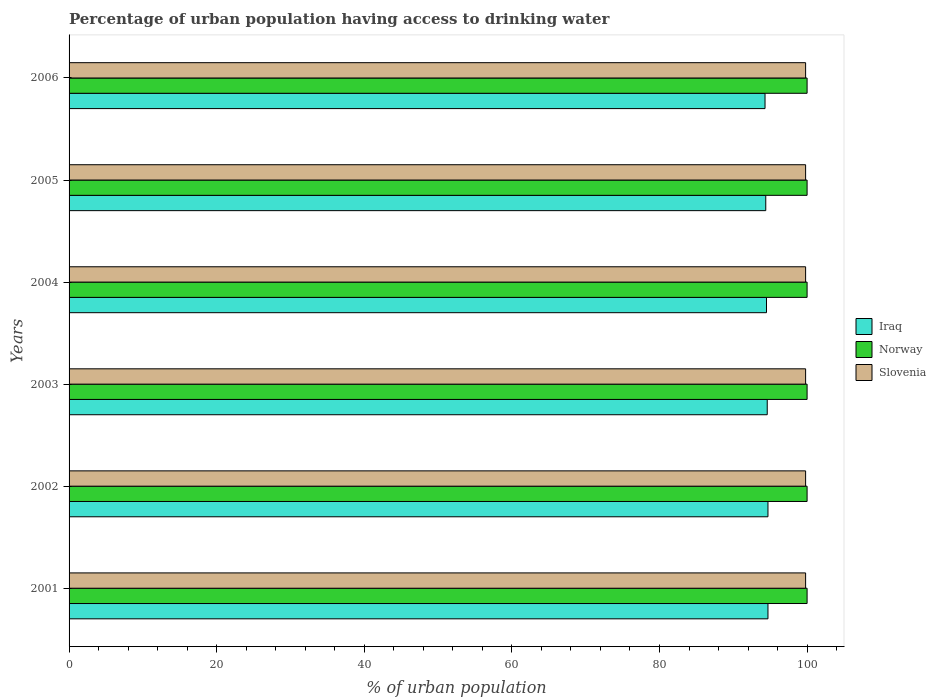How many groups of bars are there?
Make the answer very short. 6. Are the number of bars per tick equal to the number of legend labels?
Give a very brief answer. Yes. What is the label of the 5th group of bars from the top?
Provide a short and direct response. 2002. What is the percentage of urban population having access to drinking water in Slovenia in 2004?
Make the answer very short. 99.8. Across all years, what is the maximum percentage of urban population having access to drinking water in Norway?
Provide a succinct answer. 100. Across all years, what is the minimum percentage of urban population having access to drinking water in Norway?
Keep it short and to the point. 100. In which year was the percentage of urban population having access to drinking water in Norway minimum?
Provide a short and direct response. 2001. What is the total percentage of urban population having access to drinking water in Slovenia in the graph?
Keep it short and to the point. 598.8. What is the difference between the percentage of urban population having access to drinking water in Iraq in 2002 and that in 2005?
Your answer should be very brief. 0.3. What is the difference between the percentage of urban population having access to drinking water in Iraq in 2004 and the percentage of urban population having access to drinking water in Norway in 2001?
Provide a short and direct response. -5.5. In the year 2002, what is the difference between the percentage of urban population having access to drinking water in Iraq and percentage of urban population having access to drinking water in Norway?
Ensure brevity in your answer.  -5.3. In how many years, is the percentage of urban population having access to drinking water in Norway greater than 80 %?
Provide a short and direct response. 6. Is the percentage of urban population having access to drinking water in Norway in 2001 less than that in 2003?
Provide a succinct answer. No. Is the difference between the percentage of urban population having access to drinking water in Iraq in 2002 and 2006 greater than the difference between the percentage of urban population having access to drinking water in Norway in 2002 and 2006?
Give a very brief answer. Yes. What is the difference between the highest and the second highest percentage of urban population having access to drinking water in Norway?
Give a very brief answer. 0. What is the difference between the highest and the lowest percentage of urban population having access to drinking water in Norway?
Offer a very short reply. 0. What does the 1st bar from the top in 2006 represents?
Provide a short and direct response. Slovenia. What does the 1st bar from the bottom in 2003 represents?
Provide a succinct answer. Iraq. How many bars are there?
Provide a short and direct response. 18. How many years are there in the graph?
Offer a terse response. 6. What is the difference between two consecutive major ticks on the X-axis?
Your response must be concise. 20. Are the values on the major ticks of X-axis written in scientific E-notation?
Make the answer very short. No. Does the graph contain any zero values?
Your response must be concise. No. Does the graph contain grids?
Provide a short and direct response. No. Where does the legend appear in the graph?
Ensure brevity in your answer.  Center right. How many legend labels are there?
Provide a short and direct response. 3. What is the title of the graph?
Your response must be concise. Percentage of urban population having access to drinking water. Does "Jamaica" appear as one of the legend labels in the graph?
Ensure brevity in your answer.  No. What is the label or title of the X-axis?
Provide a short and direct response. % of urban population. What is the label or title of the Y-axis?
Offer a very short reply. Years. What is the % of urban population in Iraq in 2001?
Provide a succinct answer. 94.7. What is the % of urban population of Slovenia in 2001?
Give a very brief answer. 99.8. What is the % of urban population of Iraq in 2002?
Give a very brief answer. 94.7. What is the % of urban population in Slovenia in 2002?
Your answer should be compact. 99.8. What is the % of urban population of Iraq in 2003?
Keep it short and to the point. 94.6. What is the % of urban population of Slovenia in 2003?
Give a very brief answer. 99.8. What is the % of urban population in Iraq in 2004?
Make the answer very short. 94.5. What is the % of urban population of Slovenia in 2004?
Provide a succinct answer. 99.8. What is the % of urban population in Iraq in 2005?
Make the answer very short. 94.4. What is the % of urban population of Norway in 2005?
Your answer should be very brief. 100. What is the % of urban population in Slovenia in 2005?
Offer a very short reply. 99.8. What is the % of urban population in Iraq in 2006?
Your answer should be very brief. 94.3. What is the % of urban population of Norway in 2006?
Your answer should be compact. 100. What is the % of urban population in Slovenia in 2006?
Your response must be concise. 99.8. Across all years, what is the maximum % of urban population of Iraq?
Your answer should be compact. 94.7. Across all years, what is the maximum % of urban population in Norway?
Your answer should be compact. 100. Across all years, what is the maximum % of urban population of Slovenia?
Ensure brevity in your answer.  99.8. Across all years, what is the minimum % of urban population in Iraq?
Give a very brief answer. 94.3. Across all years, what is the minimum % of urban population of Norway?
Keep it short and to the point. 100. Across all years, what is the minimum % of urban population of Slovenia?
Your response must be concise. 99.8. What is the total % of urban population in Iraq in the graph?
Give a very brief answer. 567.2. What is the total % of urban population in Norway in the graph?
Ensure brevity in your answer.  600. What is the total % of urban population of Slovenia in the graph?
Your response must be concise. 598.8. What is the difference between the % of urban population of Slovenia in 2001 and that in 2003?
Your answer should be very brief. 0. What is the difference between the % of urban population of Iraq in 2001 and that in 2004?
Offer a terse response. 0.2. What is the difference between the % of urban population in Norway in 2001 and that in 2004?
Make the answer very short. 0. What is the difference between the % of urban population in Iraq in 2001 and that in 2005?
Ensure brevity in your answer.  0.3. What is the difference between the % of urban population in Norway in 2001 and that in 2005?
Offer a very short reply. 0. What is the difference between the % of urban population in Iraq in 2001 and that in 2006?
Your response must be concise. 0.4. What is the difference between the % of urban population in Slovenia in 2001 and that in 2006?
Offer a very short reply. 0. What is the difference between the % of urban population in Iraq in 2002 and that in 2003?
Offer a terse response. 0.1. What is the difference between the % of urban population of Norway in 2002 and that in 2003?
Keep it short and to the point. 0. What is the difference between the % of urban population in Slovenia in 2002 and that in 2003?
Your answer should be compact. 0. What is the difference between the % of urban population of Iraq in 2002 and that in 2004?
Ensure brevity in your answer.  0.2. What is the difference between the % of urban population in Norway in 2002 and that in 2004?
Your answer should be very brief. 0. What is the difference between the % of urban population of Slovenia in 2002 and that in 2004?
Provide a short and direct response. 0. What is the difference between the % of urban population in Slovenia in 2002 and that in 2006?
Your answer should be very brief. 0. What is the difference between the % of urban population in Iraq in 2003 and that in 2004?
Make the answer very short. 0.1. What is the difference between the % of urban population in Norway in 2003 and that in 2004?
Give a very brief answer. 0. What is the difference between the % of urban population in Iraq in 2003 and that in 2005?
Keep it short and to the point. 0.2. What is the difference between the % of urban population of Norway in 2003 and that in 2005?
Offer a terse response. 0. What is the difference between the % of urban population of Slovenia in 2003 and that in 2005?
Offer a very short reply. 0. What is the difference between the % of urban population in Norway in 2003 and that in 2006?
Provide a succinct answer. 0. What is the difference between the % of urban population in Slovenia in 2003 and that in 2006?
Ensure brevity in your answer.  0. What is the difference between the % of urban population of Iraq in 2004 and that in 2005?
Provide a short and direct response. 0.1. What is the difference between the % of urban population in Iraq in 2004 and that in 2006?
Your answer should be very brief. 0.2. What is the difference between the % of urban population of Norway in 2005 and that in 2006?
Your answer should be very brief. 0. What is the difference between the % of urban population in Slovenia in 2005 and that in 2006?
Provide a short and direct response. 0. What is the difference between the % of urban population of Iraq in 2001 and the % of urban population of Norway in 2002?
Keep it short and to the point. -5.3. What is the difference between the % of urban population of Iraq in 2001 and the % of urban population of Slovenia in 2002?
Offer a very short reply. -5.1. What is the difference between the % of urban population in Norway in 2001 and the % of urban population in Slovenia in 2002?
Provide a short and direct response. 0.2. What is the difference between the % of urban population in Iraq in 2001 and the % of urban population in Norway in 2003?
Your answer should be very brief. -5.3. What is the difference between the % of urban population of Norway in 2001 and the % of urban population of Slovenia in 2003?
Your answer should be very brief. 0.2. What is the difference between the % of urban population of Iraq in 2001 and the % of urban population of Norway in 2005?
Give a very brief answer. -5.3. What is the difference between the % of urban population in Iraq in 2001 and the % of urban population in Slovenia in 2005?
Offer a terse response. -5.1. What is the difference between the % of urban population of Norway in 2001 and the % of urban population of Slovenia in 2005?
Give a very brief answer. 0.2. What is the difference between the % of urban population in Iraq in 2001 and the % of urban population in Norway in 2006?
Make the answer very short. -5.3. What is the difference between the % of urban population of Iraq in 2001 and the % of urban population of Slovenia in 2006?
Keep it short and to the point. -5.1. What is the difference between the % of urban population in Iraq in 2002 and the % of urban population in Norway in 2003?
Provide a succinct answer. -5.3. What is the difference between the % of urban population in Norway in 2002 and the % of urban population in Slovenia in 2003?
Offer a terse response. 0.2. What is the difference between the % of urban population of Norway in 2002 and the % of urban population of Slovenia in 2004?
Your answer should be compact. 0.2. What is the difference between the % of urban population of Iraq in 2002 and the % of urban population of Norway in 2005?
Offer a very short reply. -5.3. What is the difference between the % of urban population of Iraq in 2002 and the % of urban population of Slovenia in 2006?
Offer a terse response. -5.1. What is the difference between the % of urban population of Norway in 2002 and the % of urban population of Slovenia in 2006?
Your answer should be compact. 0.2. What is the difference between the % of urban population in Iraq in 2003 and the % of urban population in Norway in 2004?
Offer a very short reply. -5.4. What is the difference between the % of urban population in Iraq in 2003 and the % of urban population in Slovenia in 2004?
Offer a very short reply. -5.2. What is the difference between the % of urban population of Iraq in 2003 and the % of urban population of Norway in 2005?
Your answer should be compact. -5.4. What is the difference between the % of urban population of Norway in 2003 and the % of urban population of Slovenia in 2006?
Make the answer very short. 0.2. What is the difference between the % of urban population in Iraq in 2004 and the % of urban population in Norway in 2006?
Provide a short and direct response. -5.5. What is the difference between the % of urban population in Norway in 2004 and the % of urban population in Slovenia in 2006?
Provide a succinct answer. 0.2. What is the difference between the % of urban population of Iraq in 2005 and the % of urban population of Slovenia in 2006?
Make the answer very short. -5.4. What is the average % of urban population of Iraq per year?
Offer a very short reply. 94.53. What is the average % of urban population of Slovenia per year?
Keep it short and to the point. 99.8. In the year 2001, what is the difference between the % of urban population in Norway and % of urban population in Slovenia?
Give a very brief answer. 0.2. In the year 2002, what is the difference between the % of urban population of Iraq and % of urban population of Norway?
Ensure brevity in your answer.  -5.3. In the year 2002, what is the difference between the % of urban population in Iraq and % of urban population in Slovenia?
Your answer should be very brief. -5.1. In the year 2004, what is the difference between the % of urban population in Iraq and % of urban population in Norway?
Keep it short and to the point. -5.5. In the year 2005, what is the difference between the % of urban population of Iraq and % of urban population of Slovenia?
Give a very brief answer. -5.4. In the year 2005, what is the difference between the % of urban population in Norway and % of urban population in Slovenia?
Your answer should be compact. 0.2. In the year 2006, what is the difference between the % of urban population of Iraq and % of urban population of Norway?
Ensure brevity in your answer.  -5.7. In the year 2006, what is the difference between the % of urban population of Iraq and % of urban population of Slovenia?
Offer a terse response. -5.5. In the year 2006, what is the difference between the % of urban population of Norway and % of urban population of Slovenia?
Make the answer very short. 0.2. What is the ratio of the % of urban population in Iraq in 2001 to that in 2002?
Give a very brief answer. 1. What is the ratio of the % of urban population in Norway in 2001 to that in 2002?
Give a very brief answer. 1. What is the ratio of the % of urban population in Slovenia in 2001 to that in 2002?
Your response must be concise. 1. What is the ratio of the % of urban population of Slovenia in 2001 to that in 2003?
Your answer should be very brief. 1. What is the ratio of the % of urban population in Iraq in 2001 to that in 2005?
Offer a terse response. 1. What is the ratio of the % of urban population in Norway in 2001 to that in 2005?
Make the answer very short. 1. What is the ratio of the % of urban population in Slovenia in 2001 to that in 2005?
Your answer should be compact. 1. What is the ratio of the % of urban population in Iraq in 2001 to that in 2006?
Offer a very short reply. 1. What is the ratio of the % of urban population in Norway in 2001 to that in 2006?
Your answer should be very brief. 1. What is the ratio of the % of urban population in Slovenia in 2001 to that in 2006?
Offer a terse response. 1. What is the ratio of the % of urban population in Norway in 2002 to that in 2003?
Ensure brevity in your answer.  1. What is the ratio of the % of urban population in Iraq in 2002 to that in 2004?
Make the answer very short. 1. What is the ratio of the % of urban population in Norway in 2002 to that in 2004?
Offer a terse response. 1. What is the ratio of the % of urban population in Iraq in 2002 to that in 2005?
Provide a succinct answer. 1. What is the ratio of the % of urban population of Slovenia in 2002 to that in 2005?
Keep it short and to the point. 1. What is the ratio of the % of urban population of Norway in 2002 to that in 2006?
Provide a succinct answer. 1. What is the ratio of the % of urban population of Iraq in 2003 to that in 2004?
Your response must be concise. 1. What is the ratio of the % of urban population of Slovenia in 2003 to that in 2004?
Provide a succinct answer. 1. What is the ratio of the % of urban population of Iraq in 2003 to that in 2005?
Give a very brief answer. 1. What is the ratio of the % of urban population in Iraq in 2003 to that in 2006?
Provide a succinct answer. 1. What is the ratio of the % of urban population in Slovenia in 2003 to that in 2006?
Provide a succinct answer. 1. What is the ratio of the % of urban population in Slovenia in 2004 to that in 2005?
Offer a terse response. 1. What is the ratio of the % of urban population of Norway in 2004 to that in 2006?
Keep it short and to the point. 1. What is the ratio of the % of urban population in Slovenia in 2004 to that in 2006?
Make the answer very short. 1. What is the ratio of the % of urban population in Norway in 2005 to that in 2006?
Keep it short and to the point. 1. What is the difference between the highest and the second highest % of urban population of Norway?
Offer a very short reply. 0. What is the difference between the highest and the lowest % of urban population of Iraq?
Ensure brevity in your answer.  0.4. What is the difference between the highest and the lowest % of urban population of Norway?
Give a very brief answer. 0. 